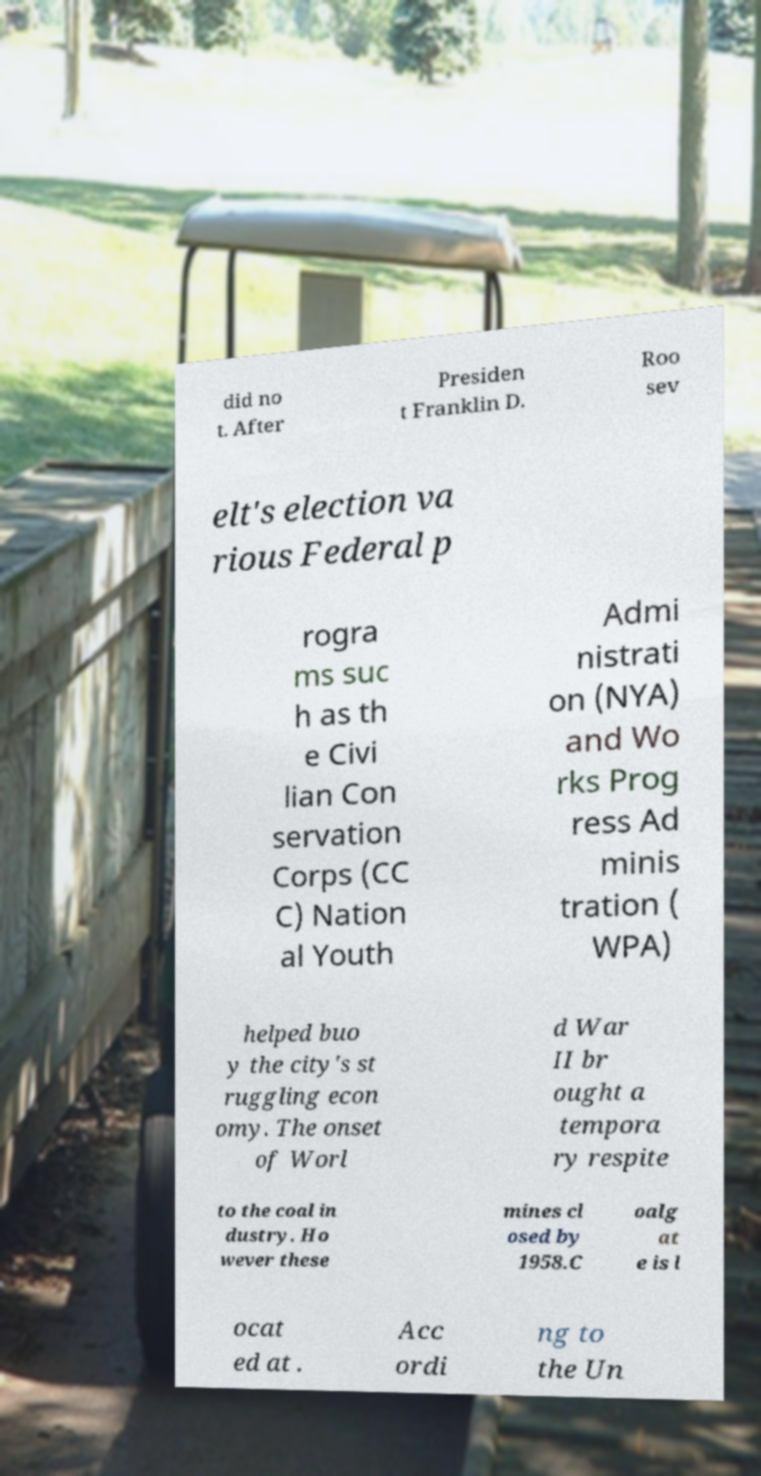Please read and relay the text visible in this image. What does it say? did no t. After Presiden t Franklin D. Roo sev elt's election va rious Federal p rogra ms suc h as th e Civi lian Con servation Corps (CC C) Nation al Youth Admi nistrati on (NYA) and Wo rks Prog ress Ad minis tration ( WPA) helped buo y the city's st ruggling econ omy. The onset of Worl d War II br ought a tempora ry respite to the coal in dustry. Ho wever these mines cl osed by 1958.C oalg at e is l ocat ed at . Acc ordi ng to the Un 